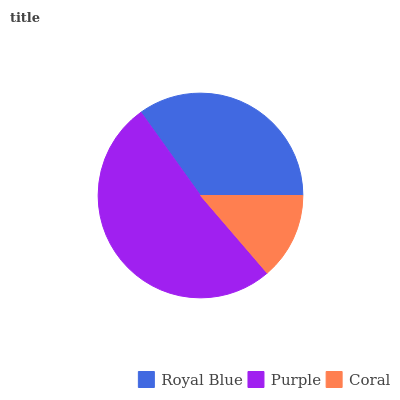Is Coral the minimum?
Answer yes or no. Yes. Is Purple the maximum?
Answer yes or no. Yes. Is Purple the minimum?
Answer yes or no. No. Is Coral the maximum?
Answer yes or no. No. Is Purple greater than Coral?
Answer yes or no. Yes. Is Coral less than Purple?
Answer yes or no. Yes. Is Coral greater than Purple?
Answer yes or no. No. Is Purple less than Coral?
Answer yes or no. No. Is Royal Blue the high median?
Answer yes or no. Yes. Is Royal Blue the low median?
Answer yes or no. Yes. Is Coral the high median?
Answer yes or no. No. Is Coral the low median?
Answer yes or no. No. 